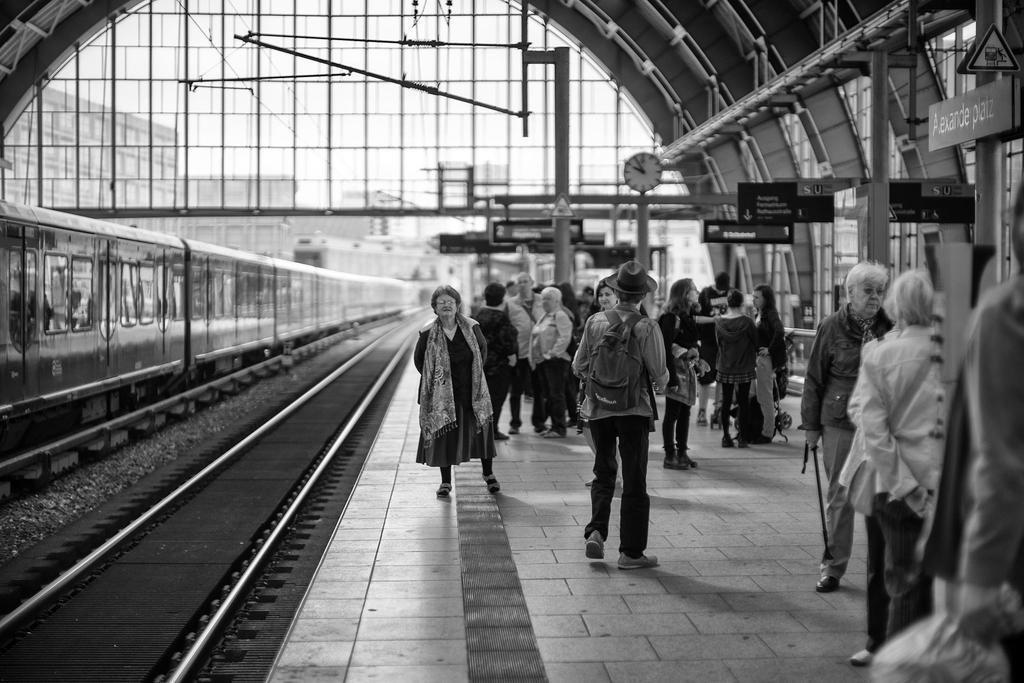Describe this image in one or two sentences. It is the black and white image in which we can see there is a train on the railway track. On the right side there is a platform on which there are so many people. In the background there are buildings. On the right side there are poles to which there are wires. In the middle there is a clock attached to the pole. Beside the clock there are boards. 